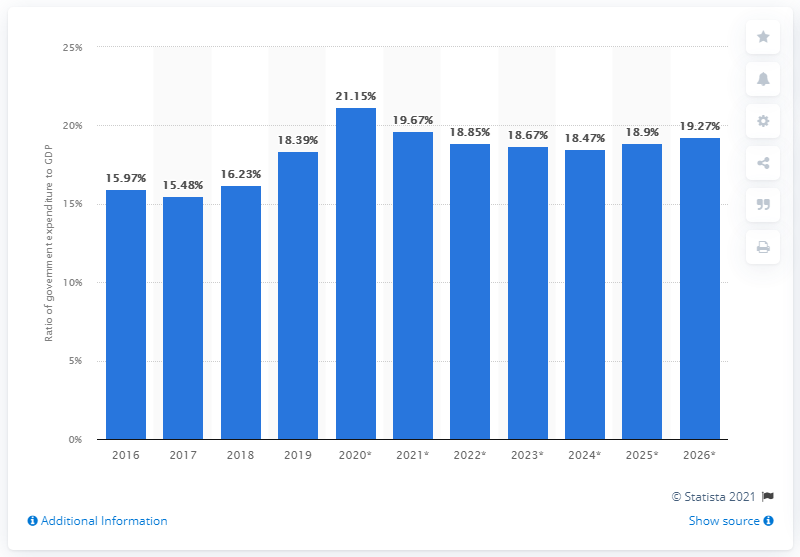Indicate a few pertinent items in this graphic. In 2019, government expenditure represented 18.47% of Uganda's gross domestic product. 